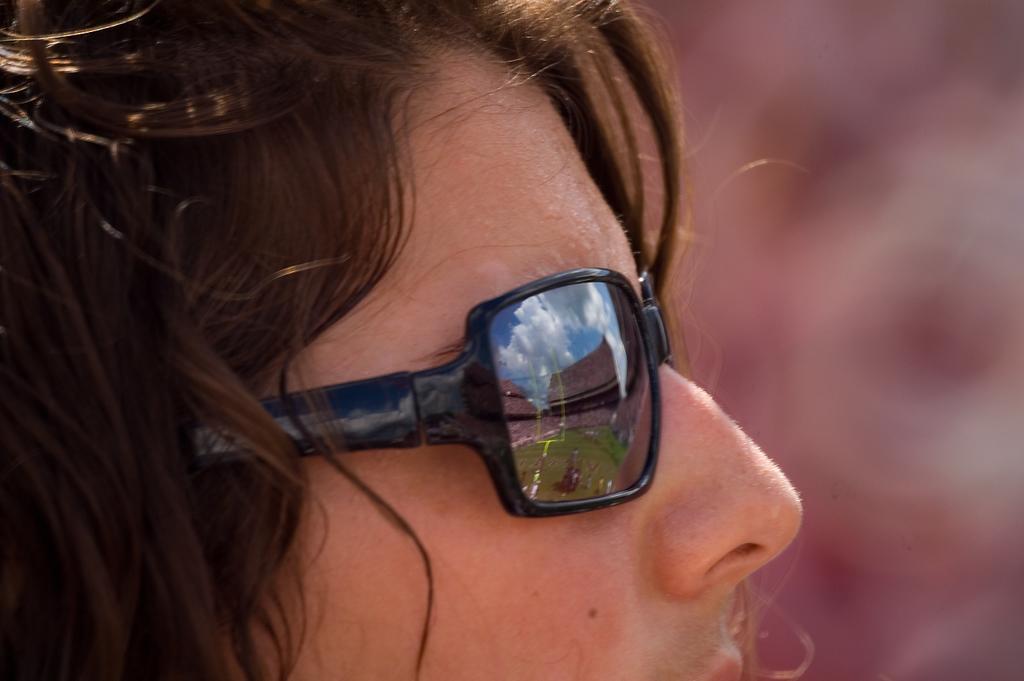Please provide a concise description of this image. In this image we can see women wearing spectacles. 